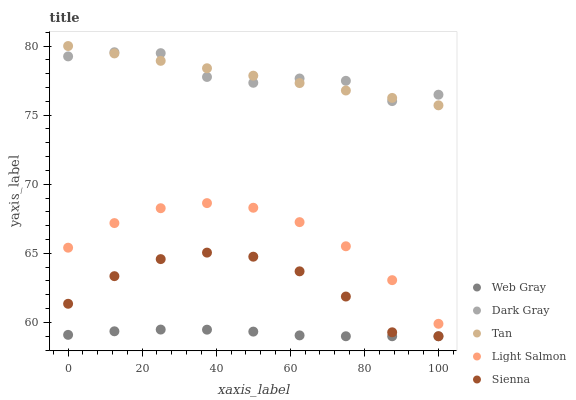Does Web Gray have the minimum area under the curve?
Answer yes or no. Yes. Does Dark Gray have the maximum area under the curve?
Answer yes or no. Yes. Does Sienna have the minimum area under the curve?
Answer yes or no. No. Does Sienna have the maximum area under the curve?
Answer yes or no. No. Is Tan the smoothest?
Answer yes or no. Yes. Is Dark Gray the roughest?
Answer yes or no. Yes. Is Sienna the smoothest?
Answer yes or no. No. Is Sienna the roughest?
Answer yes or no. No. Does Sienna have the lowest value?
Answer yes or no. Yes. Does Tan have the lowest value?
Answer yes or no. No. Does Tan have the highest value?
Answer yes or no. Yes. Does Sienna have the highest value?
Answer yes or no. No. Is Sienna less than Dark Gray?
Answer yes or no. Yes. Is Tan greater than Web Gray?
Answer yes or no. Yes. Does Tan intersect Dark Gray?
Answer yes or no. Yes. Is Tan less than Dark Gray?
Answer yes or no. No. Is Tan greater than Dark Gray?
Answer yes or no. No. Does Sienna intersect Dark Gray?
Answer yes or no. No. 